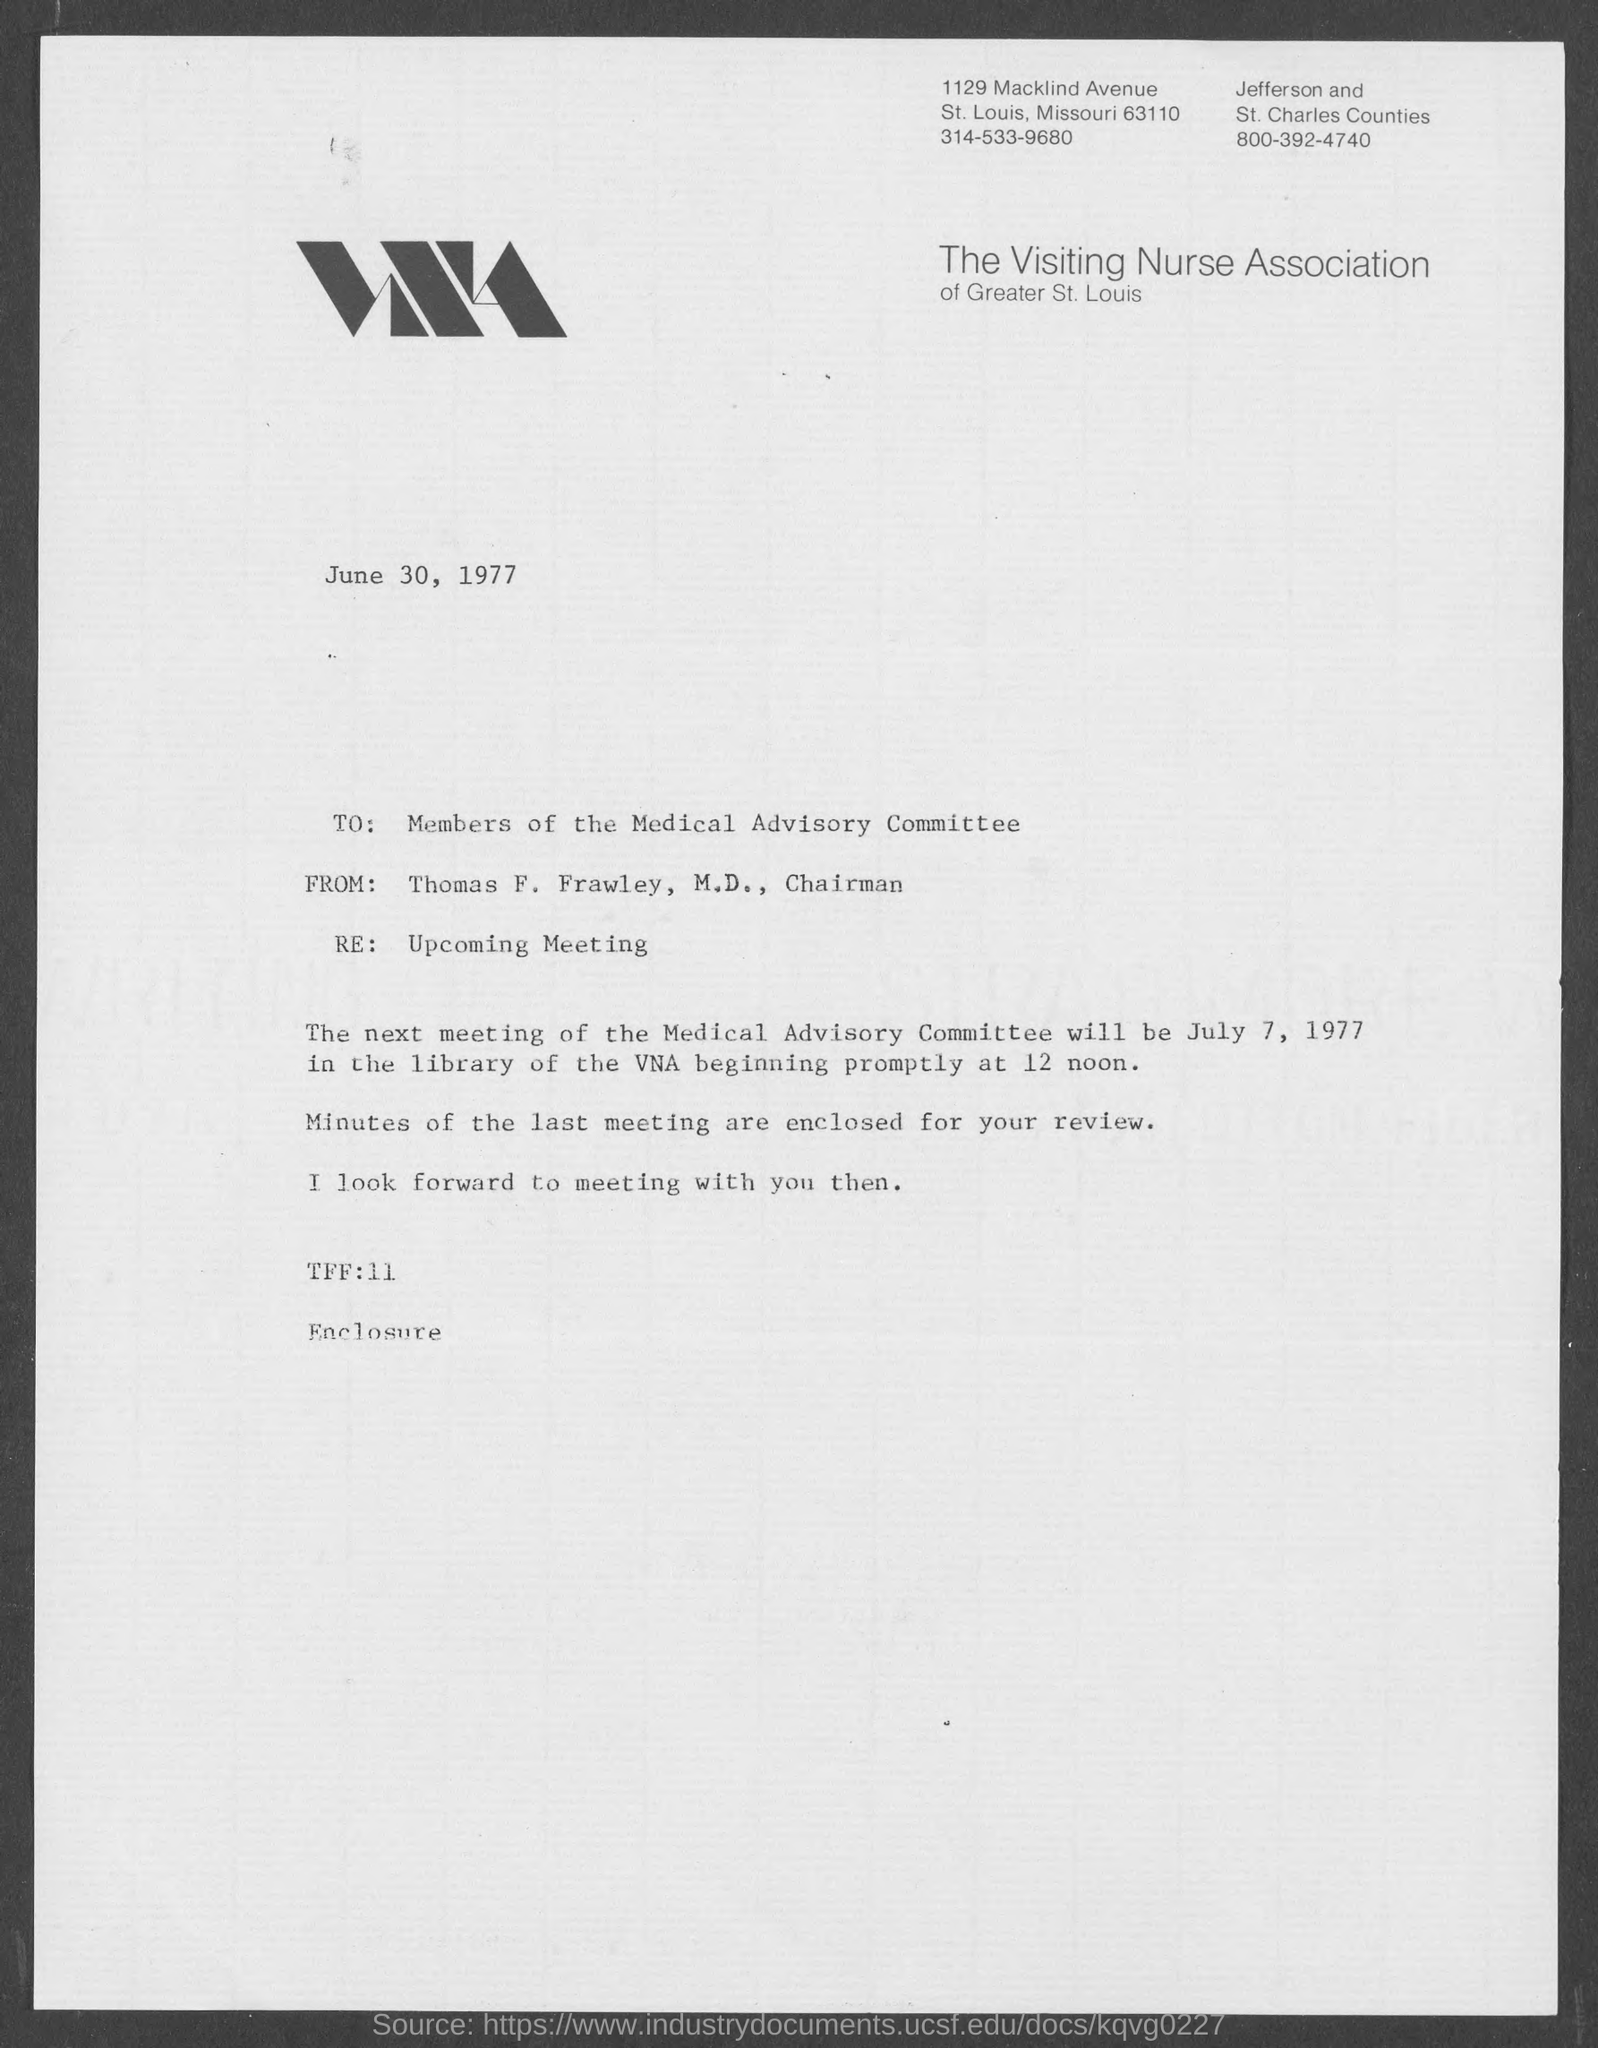Point out several critical features in this image. Thomas F. Frawley, M.D., currently holds the position of Chairman. The Visiting Nurse Association of Greater St. Louis can be contacted by dialing 314-533-9680, which is located in St. Louis County. The from address in a memorandum is "Thomas F. Frawley, M.D.". The memorandum is dated June 30, 1977. The subject of the memorandum is an upcoming meeting. 